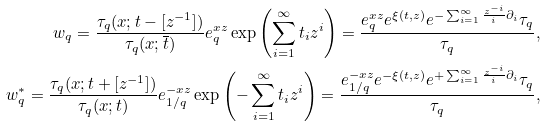<formula> <loc_0><loc_0><loc_500><loc_500>w _ { q } = \frac { \tau _ { q } ( x ; t - [ z ^ { - 1 } ] ) } { \tau _ { q } ( x ; \overline { t } ) } e _ { q } ^ { x z } \exp \left ( \sum _ { i = 1 } ^ { \infty } t _ { i } z ^ { i } \right ) = \frac { e _ { q } ^ { x z } e ^ { \xi ( t , z ) } e ^ { - \sum _ { i = 1 } ^ { \infty } \frac { z ^ { - i } } { i } \partial _ { i } } \tau _ { q } } { \tau _ { q } } , \\ w _ { q } ^ { * } = \frac { \tau _ { q } ( x ; t + [ z ^ { - 1 } ] ) } { \tau _ { q } ( x ; t ) } e _ { 1 / q } ^ { - x z } \exp \left ( - \sum _ { i = 1 } ^ { \infty } t _ { i } z ^ { i } \right ) = \frac { e _ { 1 / q } ^ { - x z } e ^ { - \xi ( t , z ) } e ^ { + \sum _ { i = 1 } ^ { \infty } \frac { z ^ { - i } } { i } \partial _ { i } } \tau _ { q } } { \tau _ { q } } ,</formula> 